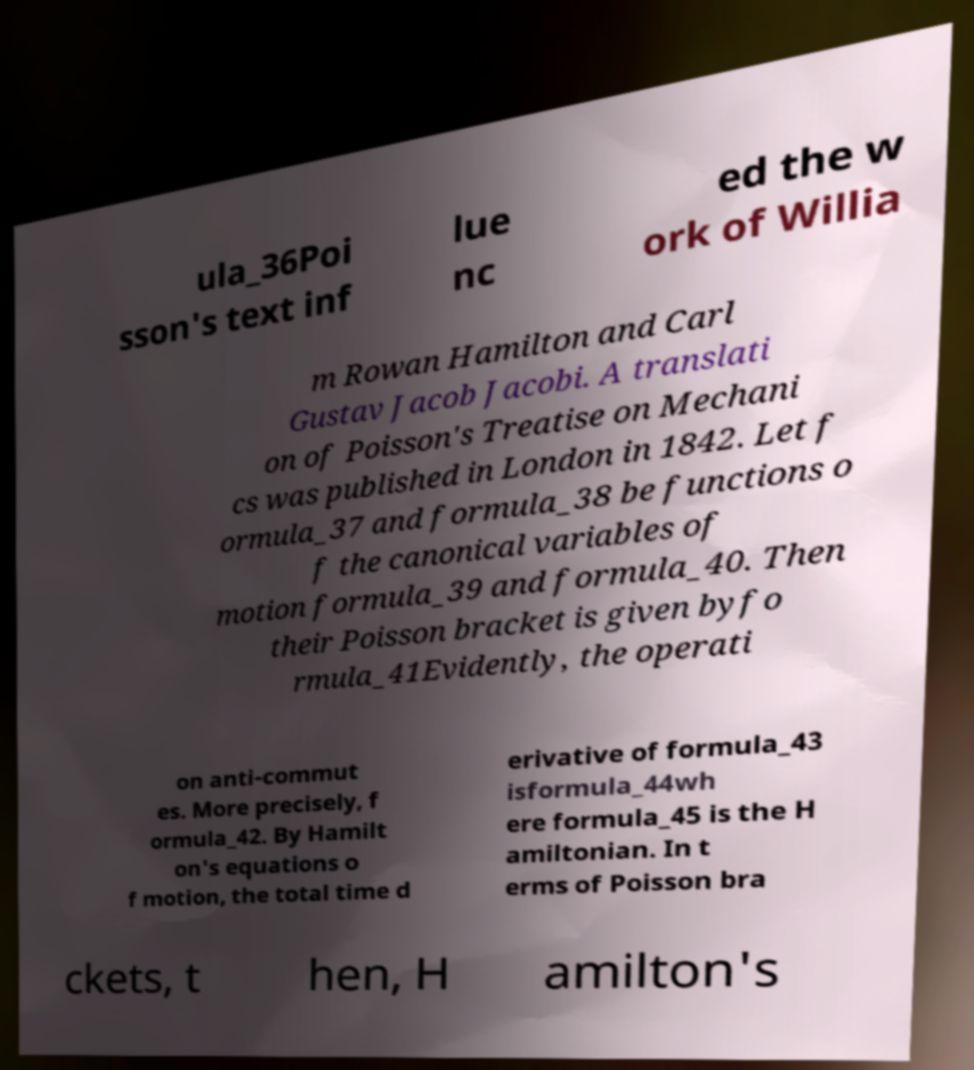Could you extract and type out the text from this image? ula_36Poi sson's text inf lue nc ed the w ork of Willia m Rowan Hamilton and Carl Gustav Jacob Jacobi. A translati on of Poisson's Treatise on Mechani cs was published in London in 1842. Let f ormula_37 and formula_38 be functions o f the canonical variables of motion formula_39 and formula_40. Then their Poisson bracket is given byfo rmula_41Evidently, the operati on anti-commut es. More precisely, f ormula_42. By Hamilt on's equations o f motion, the total time d erivative of formula_43 isformula_44wh ere formula_45 is the H amiltonian. In t erms of Poisson bra ckets, t hen, H amilton's 